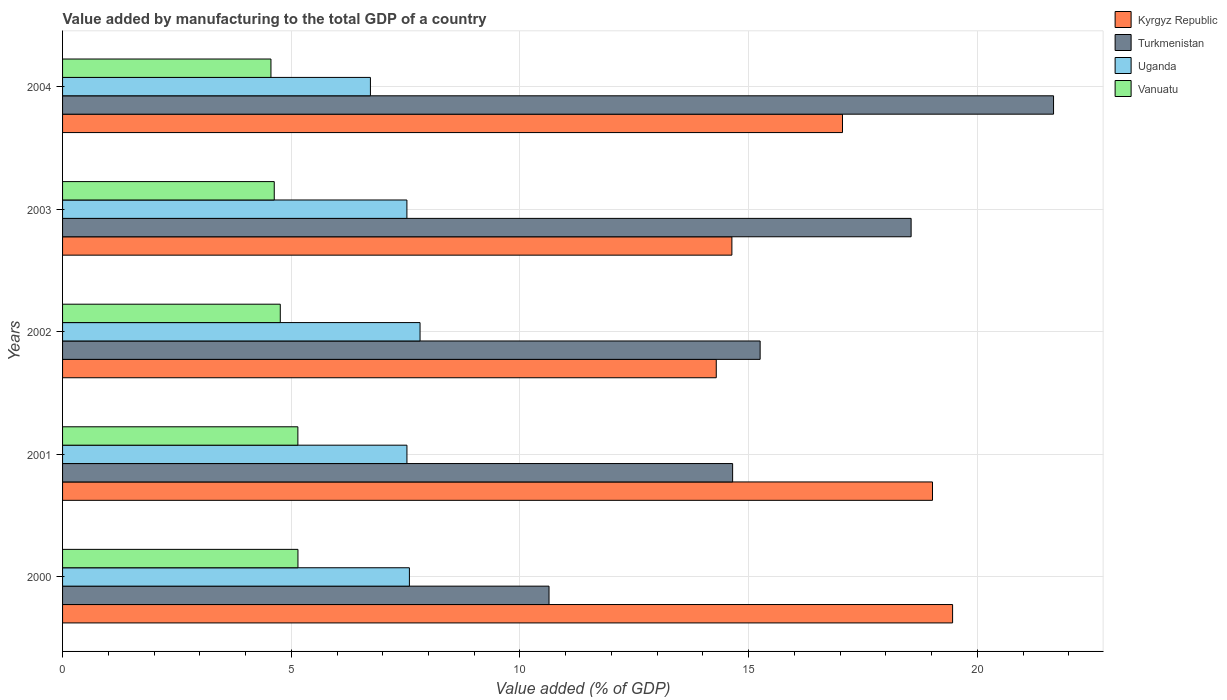How many different coloured bars are there?
Keep it short and to the point. 4. How many groups of bars are there?
Offer a very short reply. 5. How many bars are there on the 4th tick from the top?
Your response must be concise. 4. How many bars are there on the 3rd tick from the bottom?
Offer a very short reply. 4. What is the value added by manufacturing to the total GDP in Turkmenistan in 2000?
Provide a succinct answer. 10.64. Across all years, what is the maximum value added by manufacturing to the total GDP in Turkmenistan?
Your response must be concise. 21.67. Across all years, what is the minimum value added by manufacturing to the total GDP in Kyrgyz Republic?
Your answer should be compact. 14.29. What is the total value added by manufacturing to the total GDP in Uganda in the graph?
Your response must be concise. 37.19. What is the difference between the value added by manufacturing to the total GDP in Uganda in 2003 and that in 2004?
Your answer should be compact. 0.8. What is the difference between the value added by manufacturing to the total GDP in Kyrgyz Republic in 2001 and the value added by manufacturing to the total GDP in Turkmenistan in 2002?
Provide a succinct answer. 3.77. What is the average value added by manufacturing to the total GDP in Kyrgyz Republic per year?
Make the answer very short. 16.89. In the year 2004, what is the difference between the value added by manufacturing to the total GDP in Uganda and value added by manufacturing to the total GDP in Kyrgyz Republic?
Provide a succinct answer. -10.32. What is the ratio of the value added by manufacturing to the total GDP in Kyrgyz Republic in 2000 to that in 2003?
Keep it short and to the point. 1.33. What is the difference between the highest and the second highest value added by manufacturing to the total GDP in Kyrgyz Republic?
Your answer should be very brief. 0.44. What is the difference between the highest and the lowest value added by manufacturing to the total GDP in Uganda?
Keep it short and to the point. 1.09. In how many years, is the value added by manufacturing to the total GDP in Kyrgyz Republic greater than the average value added by manufacturing to the total GDP in Kyrgyz Republic taken over all years?
Provide a succinct answer. 3. Is the sum of the value added by manufacturing to the total GDP in Turkmenistan in 2001 and 2004 greater than the maximum value added by manufacturing to the total GDP in Vanuatu across all years?
Offer a very short reply. Yes. What does the 1st bar from the top in 2001 represents?
Offer a very short reply. Vanuatu. What does the 3rd bar from the bottom in 2004 represents?
Provide a short and direct response. Uganda. Is it the case that in every year, the sum of the value added by manufacturing to the total GDP in Vanuatu and value added by manufacturing to the total GDP in Turkmenistan is greater than the value added by manufacturing to the total GDP in Kyrgyz Republic?
Your answer should be compact. No. How many bars are there?
Keep it short and to the point. 20. Are all the bars in the graph horizontal?
Offer a very short reply. Yes. Where does the legend appear in the graph?
Your answer should be very brief. Top right. How many legend labels are there?
Offer a terse response. 4. How are the legend labels stacked?
Your answer should be very brief. Vertical. What is the title of the graph?
Your answer should be compact. Value added by manufacturing to the total GDP of a country. What is the label or title of the X-axis?
Ensure brevity in your answer.  Value added (% of GDP). What is the label or title of the Y-axis?
Your response must be concise. Years. What is the Value added (% of GDP) of Kyrgyz Republic in 2000?
Your response must be concise. 19.46. What is the Value added (% of GDP) in Turkmenistan in 2000?
Ensure brevity in your answer.  10.64. What is the Value added (% of GDP) in Uganda in 2000?
Make the answer very short. 7.58. What is the Value added (% of GDP) in Vanuatu in 2000?
Offer a very short reply. 5.15. What is the Value added (% of GDP) in Kyrgyz Republic in 2001?
Give a very brief answer. 19.02. What is the Value added (% of GDP) of Turkmenistan in 2001?
Provide a succinct answer. 14.65. What is the Value added (% of GDP) of Uganda in 2001?
Your response must be concise. 7.53. What is the Value added (% of GDP) of Vanuatu in 2001?
Make the answer very short. 5.14. What is the Value added (% of GDP) in Kyrgyz Republic in 2002?
Give a very brief answer. 14.29. What is the Value added (% of GDP) of Turkmenistan in 2002?
Offer a terse response. 15.25. What is the Value added (% of GDP) of Uganda in 2002?
Provide a succinct answer. 7.82. What is the Value added (% of GDP) of Vanuatu in 2002?
Give a very brief answer. 4.76. What is the Value added (% of GDP) in Kyrgyz Republic in 2003?
Give a very brief answer. 14.63. What is the Value added (% of GDP) in Turkmenistan in 2003?
Offer a very short reply. 18.55. What is the Value added (% of GDP) of Uganda in 2003?
Give a very brief answer. 7.53. What is the Value added (% of GDP) of Vanuatu in 2003?
Provide a short and direct response. 4.63. What is the Value added (% of GDP) of Kyrgyz Republic in 2004?
Offer a terse response. 17.05. What is the Value added (% of GDP) in Turkmenistan in 2004?
Ensure brevity in your answer.  21.67. What is the Value added (% of GDP) in Uganda in 2004?
Your response must be concise. 6.73. What is the Value added (% of GDP) of Vanuatu in 2004?
Ensure brevity in your answer.  4.56. Across all years, what is the maximum Value added (% of GDP) of Kyrgyz Republic?
Offer a terse response. 19.46. Across all years, what is the maximum Value added (% of GDP) of Turkmenistan?
Your response must be concise. 21.67. Across all years, what is the maximum Value added (% of GDP) of Uganda?
Provide a short and direct response. 7.82. Across all years, what is the maximum Value added (% of GDP) in Vanuatu?
Offer a very short reply. 5.15. Across all years, what is the minimum Value added (% of GDP) in Kyrgyz Republic?
Your answer should be very brief. 14.29. Across all years, what is the minimum Value added (% of GDP) in Turkmenistan?
Ensure brevity in your answer.  10.64. Across all years, what is the minimum Value added (% of GDP) of Uganda?
Your response must be concise. 6.73. Across all years, what is the minimum Value added (% of GDP) in Vanuatu?
Offer a terse response. 4.56. What is the total Value added (% of GDP) in Kyrgyz Republic in the graph?
Offer a very short reply. 84.46. What is the total Value added (% of GDP) in Turkmenistan in the graph?
Your answer should be very brief. 80.75. What is the total Value added (% of GDP) of Uganda in the graph?
Offer a terse response. 37.19. What is the total Value added (% of GDP) of Vanuatu in the graph?
Offer a very short reply. 24.23. What is the difference between the Value added (% of GDP) of Kyrgyz Republic in 2000 and that in 2001?
Your answer should be compact. 0.44. What is the difference between the Value added (% of GDP) of Turkmenistan in 2000 and that in 2001?
Keep it short and to the point. -4.01. What is the difference between the Value added (% of GDP) in Uganda in 2000 and that in 2001?
Give a very brief answer. 0.05. What is the difference between the Value added (% of GDP) of Vanuatu in 2000 and that in 2001?
Your answer should be compact. 0. What is the difference between the Value added (% of GDP) in Kyrgyz Republic in 2000 and that in 2002?
Keep it short and to the point. 5.17. What is the difference between the Value added (% of GDP) in Turkmenistan in 2000 and that in 2002?
Offer a terse response. -4.62. What is the difference between the Value added (% of GDP) in Uganda in 2000 and that in 2002?
Offer a very short reply. -0.23. What is the difference between the Value added (% of GDP) of Vanuatu in 2000 and that in 2002?
Make the answer very short. 0.39. What is the difference between the Value added (% of GDP) in Kyrgyz Republic in 2000 and that in 2003?
Give a very brief answer. 4.83. What is the difference between the Value added (% of GDP) in Turkmenistan in 2000 and that in 2003?
Offer a very short reply. -7.92. What is the difference between the Value added (% of GDP) in Uganda in 2000 and that in 2003?
Give a very brief answer. 0.05. What is the difference between the Value added (% of GDP) of Vanuatu in 2000 and that in 2003?
Give a very brief answer. 0.52. What is the difference between the Value added (% of GDP) of Kyrgyz Republic in 2000 and that in 2004?
Your response must be concise. 2.41. What is the difference between the Value added (% of GDP) in Turkmenistan in 2000 and that in 2004?
Keep it short and to the point. -11.03. What is the difference between the Value added (% of GDP) in Uganda in 2000 and that in 2004?
Provide a short and direct response. 0.85. What is the difference between the Value added (% of GDP) in Vanuatu in 2000 and that in 2004?
Ensure brevity in your answer.  0.59. What is the difference between the Value added (% of GDP) in Kyrgyz Republic in 2001 and that in 2002?
Your answer should be compact. 4.73. What is the difference between the Value added (% of GDP) of Turkmenistan in 2001 and that in 2002?
Provide a succinct answer. -0.6. What is the difference between the Value added (% of GDP) in Uganda in 2001 and that in 2002?
Your response must be concise. -0.29. What is the difference between the Value added (% of GDP) in Vanuatu in 2001 and that in 2002?
Your answer should be very brief. 0.38. What is the difference between the Value added (% of GDP) of Kyrgyz Republic in 2001 and that in 2003?
Offer a very short reply. 4.39. What is the difference between the Value added (% of GDP) of Turkmenistan in 2001 and that in 2003?
Offer a terse response. -3.9. What is the difference between the Value added (% of GDP) of Vanuatu in 2001 and that in 2003?
Your answer should be compact. 0.52. What is the difference between the Value added (% of GDP) in Kyrgyz Republic in 2001 and that in 2004?
Give a very brief answer. 1.97. What is the difference between the Value added (% of GDP) of Turkmenistan in 2001 and that in 2004?
Ensure brevity in your answer.  -7.02. What is the difference between the Value added (% of GDP) in Uganda in 2001 and that in 2004?
Make the answer very short. 0.8. What is the difference between the Value added (% of GDP) in Vanuatu in 2001 and that in 2004?
Provide a succinct answer. 0.59. What is the difference between the Value added (% of GDP) of Kyrgyz Republic in 2002 and that in 2003?
Your response must be concise. -0.34. What is the difference between the Value added (% of GDP) in Turkmenistan in 2002 and that in 2003?
Keep it short and to the point. -3.3. What is the difference between the Value added (% of GDP) of Uganda in 2002 and that in 2003?
Offer a terse response. 0.29. What is the difference between the Value added (% of GDP) of Vanuatu in 2002 and that in 2003?
Offer a very short reply. 0.13. What is the difference between the Value added (% of GDP) in Kyrgyz Republic in 2002 and that in 2004?
Provide a short and direct response. -2.76. What is the difference between the Value added (% of GDP) in Turkmenistan in 2002 and that in 2004?
Ensure brevity in your answer.  -6.42. What is the difference between the Value added (% of GDP) of Uganda in 2002 and that in 2004?
Offer a terse response. 1.08. What is the difference between the Value added (% of GDP) in Vanuatu in 2002 and that in 2004?
Your answer should be compact. 0.2. What is the difference between the Value added (% of GDP) in Kyrgyz Republic in 2003 and that in 2004?
Ensure brevity in your answer.  -2.42. What is the difference between the Value added (% of GDP) of Turkmenistan in 2003 and that in 2004?
Your answer should be very brief. -3.11. What is the difference between the Value added (% of GDP) of Uganda in 2003 and that in 2004?
Provide a succinct answer. 0.8. What is the difference between the Value added (% of GDP) in Vanuatu in 2003 and that in 2004?
Your answer should be compact. 0.07. What is the difference between the Value added (% of GDP) of Kyrgyz Republic in 2000 and the Value added (% of GDP) of Turkmenistan in 2001?
Give a very brief answer. 4.81. What is the difference between the Value added (% of GDP) of Kyrgyz Republic in 2000 and the Value added (% of GDP) of Uganda in 2001?
Offer a terse response. 11.93. What is the difference between the Value added (% of GDP) in Kyrgyz Republic in 2000 and the Value added (% of GDP) in Vanuatu in 2001?
Your answer should be very brief. 14.31. What is the difference between the Value added (% of GDP) of Turkmenistan in 2000 and the Value added (% of GDP) of Uganda in 2001?
Your answer should be compact. 3.11. What is the difference between the Value added (% of GDP) in Turkmenistan in 2000 and the Value added (% of GDP) in Vanuatu in 2001?
Provide a short and direct response. 5.49. What is the difference between the Value added (% of GDP) in Uganda in 2000 and the Value added (% of GDP) in Vanuatu in 2001?
Offer a terse response. 2.44. What is the difference between the Value added (% of GDP) in Kyrgyz Republic in 2000 and the Value added (% of GDP) in Turkmenistan in 2002?
Your answer should be compact. 4.21. What is the difference between the Value added (% of GDP) of Kyrgyz Republic in 2000 and the Value added (% of GDP) of Uganda in 2002?
Your response must be concise. 11.64. What is the difference between the Value added (% of GDP) in Kyrgyz Republic in 2000 and the Value added (% of GDP) in Vanuatu in 2002?
Give a very brief answer. 14.7. What is the difference between the Value added (% of GDP) in Turkmenistan in 2000 and the Value added (% of GDP) in Uganda in 2002?
Provide a succinct answer. 2.82. What is the difference between the Value added (% of GDP) in Turkmenistan in 2000 and the Value added (% of GDP) in Vanuatu in 2002?
Offer a very short reply. 5.88. What is the difference between the Value added (% of GDP) in Uganda in 2000 and the Value added (% of GDP) in Vanuatu in 2002?
Give a very brief answer. 2.82. What is the difference between the Value added (% of GDP) of Kyrgyz Republic in 2000 and the Value added (% of GDP) of Turkmenistan in 2003?
Give a very brief answer. 0.91. What is the difference between the Value added (% of GDP) of Kyrgyz Republic in 2000 and the Value added (% of GDP) of Uganda in 2003?
Offer a terse response. 11.93. What is the difference between the Value added (% of GDP) of Kyrgyz Republic in 2000 and the Value added (% of GDP) of Vanuatu in 2003?
Ensure brevity in your answer.  14.83. What is the difference between the Value added (% of GDP) in Turkmenistan in 2000 and the Value added (% of GDP) in Uganda in 2003?
Offer a very short reply. 3.11. What is the difference between the Value added (% of GDP) of Turkmenistan in 2000 and the Value added (% of GDP) of Vanuatu in 2003?
Offer a very short reply. 6.01. What is the difference between the Value added (% of GDP) of Uganda in 2000 and the Value added (% of GDP) of Vanuatu in 2003?
Give a very brief answer. 2.95. What is the difference between the Value added (% of GDP) of Kyrgyz Republic in 2000 and the Value added (% of GDP) of Turkmenistan in 2004?
Your answer should be compact. -2.21. What is the difference between the Value added (% of GDP) in Kyrgyz Republic in 2000 and the Value added (% of GDP) in Uganda in 2004?
Give a very brief answer. 12.73. What is the difference between the Value added (% of GDP) of Kyrgyz Republic in 2000 and the Value added (% of GDP) of Vanuatu in 2004?
Offer a terse response. 14.9. What is the difference between the Value added (% of GDP) of Turkmenistan in 2000 and the Value added (% of GDP) of Uganda in 2004?
Your answer should be compact. 3.9. What is the difference between the Value added (% of GDP) in Turkmenistan in 2000 and the Value added (% of GDP) in Vanuatu in 2004?
Your response must be concise. 6.08. What is the difference between the Value added (% of GDP) of Uganda in 2000 and the Value added (% of GDP) of Vanuatu in 2004?
Your response must be concise. 3.03. What is the difference between the Value added (% of GDP) of Kyrgyz Republic in 2001 and the Value added (% of GDP) of Turkmenistan in 2002?
Ensure brevity in your answer.  3.77. What is the difference between the Value added (% of GDP) in Kyrgyz Republic in 2001 and the Value added (% of GDP) in Uganda in 2002?
Ensure brevity in your answer.  11.2. What is the difference between the Value added (% of GDP) in Kyrgyz Republic in 2001 and the Value added (% of GDP) in Vanuatu in 2002?
Your response must be concise. 14.26. What is the difference between the Value added (% of GDP) in Turkmenistan in 2001 and the Value added (% of GDP) in Uganda in 2002?
Make the answer very short. 6.83. What is the difference between the Value added (% of GDP) of Turkmenistan in 2001 and the Value added (% of GDP) of Vanuatu in 2002?
Keep it short and to the point. 9.89. What is the difference between the Value added (% of GDP) in Uganda in 2001 and the Value added (% of GDP) in Vanuatu in 2002?
Offer a terse response. 2.77. What is the difference between the Value added (% of GDP) in Kyrgyz Republic in 2001 and the Value added (% of GDP) in Turkmenistan in 2003?
Make the answer very short. 0.47. What is the difference between the Value added (% of GDP) of Kyrgyz Republic in 2001 and the Value added (% of GDP) of Uganda in 2003?
Make the answer very short. 11.49. What is the difference between the Value added (% of GDP) in Kyrgyz Republic in 2001 and the Value added (% of GDP) in Vanuatu in 2003?
Your answer should be very brief. 14.39. What is the difference between the Value added (% of GDP) of Turkmenistan in 2001 and the Value added (% of GDP) of Uganda in 2003?
Make the answer very short. 7.12. What is the difference between the Value added (% of GDP) in Turkmenistan in 2001 and the Value added (% of GDP) in Vanuatu in 2003?
Your answer should be compact. 10.02. What is the difference between the Value added (% of GDP) of Uganda in 2001 and the Value added (% of GDP) of Vanuatu in 2003?
Ensure brevity in your answer.  2.9. What is the difference between the Value added (% of GDP) in Kyrgyz Republic in 2001 and the Value added (% of GDP) in Turkmenistan in 2004?
Offer a very short reply. -2.65. What is the difference between the Value added (% of GDP) of Kyrgyz Republic in 2001 and the Value added (% of GDP) of Uganda in 2004?
Ensure brevity in your answer.  12.29. What is the difference between the Value added (% of GDP) in Kyrgyz Republic in 2001 and the Value added (% of GDP) in Vanuatu in 2004?
Ensure brevity in your answer.  14.46. What is the difference between the Value added (% of GDP) of Turkmenistan in 2001 and the Value added (% of GDP) of Uganda in 2004?
Make the answer very short. 7.92. What is the difference between the Value added (% of GDP) in Turkmenistan in 2001 and the Value added (% of GDP) in Vanuatu in 2004?
Your response must be concise. 10.09. What is the difference between the Value added (% of GDP) of Uganda in 2001 and the Value added (% of GDP) of Vanuatu in 2004?
Offer a terse response. 2.97. What is the difference between the Value added (% of GDP) in Kyrgyz Republic in 2002 and the Value added (% of GDP) in Turkmenistan in 2003?
Give a very brief answer. -4.26. What is the difference between the Value added (% of GDP) in Kyrgyz Republic in 2002 and the Value added (% of GDP) in Uganda in 2003?
Your answer should be compact. 6.76. What is the difference between the Value added (% of GDP) of Kyrgyz Republic in 2002 and the Value added (% of GDP) of Vanuatu in 2003?
Make the answer very short. 9.66. What is the difference between the Value added (% of GDP) of Turkmenistan in 2002 and the Value added (% of GDP) of Uganda in 2003?
Give a very brief answer. 7.72. What is the difference between the Value added (% of GDP) of Turkmenistan in 2002 and the Value added (% of GDP) of Vanuatu in 2003?
Offer a terse response. 10.62. What is the difference between the Value added (% of GDP) of Uganda in 2002 and the Value added (% of GDP) of Vanuatu in 2003?
Offer a very short reply. 3.19. What is the difference between the Value added (% of GDP) in Kyrgyz Republic in 2002 and the Value added (% of GDP) in Turkmenistan in 2004?
Your response must be concise. -7.37. What is the difference between the Value added (% of GDP) of Kyrgyz Republic in 2002 and the Value added (% of GDP) of Uganda in 2004?
Offer a terse response. 7.56. What is the difference between the Value added (% of GDP) in Kyrgyz Republic in 2002 and the Value added (% of GDP) in Vanuatu in 2004?
Ensure brevity in your answer.  9.74. What is the difference between the Value added (% of GDP) in Turkmenistan in 2002 and the Value added (% of GDP) in Uganda in 2004?
Keep it short and to the point. 8.52. What is the difference between the Value added (% of GDP) in Turkmenistan in 2002 and the Value added (% of GDP) in Vanuatu in 2004?
Your answer should be compact. 10.7. What is the difference between the Value added (% of GDP) in Uganda in 2002 and the Value added (% of GDP) in Vanuatu in 2004?
Your answer should be very brief. 3.26. What is the difference between the Value added (% of GDP) of Kyrgyz Republic in 2003 and the Value added (% of GDP) of Turkmenistan in 2004?
Your answer should be compact. -7.03. What is the difference between the Value added (% of GDP) in Kyrgyz Republic in 2003 and the Value added (% of GDP) in Uganda in 2004?
Ensure brevity in your answer.  7.9. What is the difference between the Value added (% of GDP) of Kyrgyz Republic in 2003 and the Value added (% of GDP) of Vanuatu in 2004?
Make the answer very short. 10.08. What is the difference between the Value added (% of GDP) in Turkmenistan in 2003 and the Value added (% of GDP) in Uganda in 2004?
Offer a terse response. 11.82. What is the difference between the Value added (% of GDP) in Turkmenistan in 2003 and the Value added (% of GDP) in Vanuatu in 2004?
Keep it short and to the point. 14. What is the difference between the Value added (% of GDP) of Uganda in 2003 and the Value added (% of GDP) of Vanuatu in 2004?
Your response must be concise. 2.97. What is the average Value added (% of GDP) of Kyrgyz Republic per year?
Your answer should be very brief. 16.89. What is the average Value added (% of GDP) in Turkmenistan per year?
Give a very brief answer. 16.15. What is the average Value added (% of GDP) of Uganda per year?
Keep it short and to the point. 7.44. What is the average Value added (% of GDP) in Vanuatu per year?
Give a very brief answer. 4.85. In the year 2000, what is the difference between the Value added (% of GDP) of Kyrgyz Republic and Value added (% of GDP) of Turkmenistan?
Keep it short and to the point. 8.82. In the year 2000, what is the difference between the Value added (% of GDP) in Kyrgyz Republic and Value added (% of GDP) in Uganda?
Provide a short and direct response. 11.88. In the year 2000, what is the difference between the Value added (% of GDP) in Kyrgyz Republic and Value added (% of GDP) in Vanuatu?
Your answer should be compact. 14.31. In the year 2000, what is the difference between the Value added (% of GDP) in Turkmenistan and Value added (% of GDP) in Uganda?
Your answer should be very brief. 3.05. In the year 2000, what is the difference between the Value added (% of GDP) in Turkmenistan and Value added (% of GDP) in Vanuatu?
Your answer should be compact. 5.49. In the year 2000, what is the difference between the Value added (% of GDP) in Uganda and Value added (% of GDP) in Vanuatu?
Offer a very short reply. 2.44. In the year 2001, what is the difference between the Value added (% of GDP) of Kyrgyz Republic and Value added (% of GDP) of Turkmenistan?
Make the answer very short. 4.37. In the year 2001, what is the difference between the Value added (% of GDP) of Kyrgyz Republic and Value added (% of GDP) of Uganda?
Ensure brevity in your answer.  11.49. In the year 2001, what is the difference between the Value added (% of GDP) of Kyrgyz Republic and Value added (% of GDP) of Vanuatu?
Ensure brevity in your answer.  13.87. In the year 2001, what is the difference between the Value added (% of GDP) of Turkmenistan and Value added (% of GDP) of Uganda?
Keep it short and to the point. 7.12. In the year 2001, what is the difference between the Value added (% of GDP) in Turkmenistan and Value added (% of GDP) in Vanuatu?
Keep it short and to the point. 9.51. In the year 2001, what is the difference between the Value added (% of GDP) of Uganda and Value added (% of GDP) of Vanuatu?
Your response must be concise. 2.38. In the year 2002, what is the difference between the Value added (% of GDP) in Kyrgyz Republic and Value added (% of GDP) in Turkmenistan?
Keep it short and to the point. -0.96. In the year 2002, what is the difference between the Value added (% of GDP) in Kyrgyz Republic and Value added (% of GDP) in Uganda?
Give a very brief answer. 6.48. In the year 2002, what is the difference between the Value added (% of GDP) of Kyrgyz Republic and Value added (% of GDP) of Vanuatu?
Provide a succinct answer. 9.53. In the year 2002, what is the difference between the Value added (% of GDP) in Turkmenistan and Value added (% of GDP) in Uganda?
Make the answer very short. 7.44. In the year 2002, what is the difference between the Value added (% of GDP) of Turkmenistan and Value added (% of GDP) of Vanuatu?
Offer a very short reply. 10.49. In the year 2002, what is the difference between the Value added (% of GDP) in Uganda and Value added (% of GDP) in Vanuatu?
Give a very brief answer. 3.06. In the year 2003, what is the difference between the Value added (% of GDP) of Kyrgyz Republic and Value added (% of GDP) of Turkmenistan?
Your response must be concise. -3.92. In the year 2003, what is the difference between the Value added (% of GDP) in Kyrgyz Republic and Value added (% of GDP) in Uganda?
Make the answer very short. 7.11. In the year 2003, what is the difference between the Value added (% of GDP) in Kyrgyz Republic and Value added (% of GDP) in Vanuatu?
Offer a terse response. 10.01. In the year 2003, what is the difference between the Value added (% of GDP) in Turkmenistan and Value added (% of GDP) in Uganda?
Your response must be concise. 11.02. In the year 2003, what is the difference between the Value added (% of GDP) in Turkmenistan and Value added (% of GDP) in Vanuatu?
Your answer should be compact. 13.92. In the year 2003, what is the difference between the Value added (% of GDP) in Uganda and Value added (% of GDP) in Vanuatu?
Offer a terse response. 2.9. In the year 2004, what is the difference between the Value added (% of GDP) in Kyrgyz Republic and Value added (% of GDP) in Turkmenistan?
Keep it short and to the point. -4.61. In the year 2004, what is the difference between the Value added (% of GDP) in Kyrgyz Republic and Value added (% of GDP) in Uganda?
Your response must be concise. 10.32. In the year 2004, what is the difference between the Value added (% of GDP) of Kyrgyz Republic and Value added (% of GDP) of Vanuatu?
Your response must be concise. 12.5. In the year 2004, what is the difference between the Value added (% of GDP) in Turkmenistan and Value added (% of GDP) in Uganda?
Give a very brief answer. 14.94. In the year 2004, what is the difference between the Value added (% of GDP) in Turkmenistan and Value added (% of GDP) in Vanuatu?
Keep it short and to the point. 17.11. In the year 2004, what is the difference between the Value added (% of GDP) in Uganda and Value added (% of GDP) in Vanuatu?
Your response must be concise. 2.17. What is the ratio of the Value added (% of GDP) of Kyrgyz Republic in 2000 to that in 2001?
Make the answer very short. 1.02. What is the ratio of the Value added (% of GDP) of Turkmenistan in 2000 to that in 2001?
Give a very brief answer. 0.73. What is the ratio of the Value added (% of GDP) in Uganda in 2000 to that in 2001?
Your response must be concise. 1.01. What is the ratio of the Value added (% of GDP) in Vanuatu in 2000 to that in 2001?
Your answer should be compact. 1. What is the ratio of the Value added (% of GDP) of Kyrgyz Republic in 2000 to that in 2002?
Your response must be concise. 1.36. What is the ratio of the Value added (% of GDP) of Turkmenistan in 2000 to that in 2002?
Your response must be concise. 0.7. What is the ratio of the Value added (% of GDP) of Uganda in 2000 to that in 2002?
Offer a very short reply. 0.97. What is the ratio of the Value added (% of GDP) in Vanuatu in 2000 to that in 2002?
Provide a short and direct response. 1.08. What is the ratio of the Value added (% of GDP) in Kyrgyz Republic in 2000 to that in 2003?
Make the answer very short. 1.33. What is the ratio of the Value added (% of GDP) in Turkmenistan in 2000 to that in 2003?
Make the answer very short. 0.57. What is the ratio of the Value added (% of GDP) of Uganda in 2000 to that in 2003?
Keep it short and to the point. 1.01. What is the ratio of the Value added (% of GDP) of Vanuatu in 2000 to that in 2003?
Ensure brevity in your answer.  1.11. What is the ratio of the Value added (% of GDP) of Kyrgyz Republic in 2000 to that in 2004?
Your response must be concise. 1.14. What is the ratio of the Value added (% of GDP) of Turkmenistan in 2000 to that in 2004?
Provide a short and direct response. 0.49. What is the ratio of the Value added (% of GDP) in Uganda in 2000 to that in 2004?
Your answer should be compact. 1.13. What is the ratio of the Value added (% of GDP) of Vanuatu in 2000 to that in 2004?
Offer a very short reply. 1.13. What is the ratio of the Value added (% of GDP) in Kyrgyz Republic in 2001 to that in 2002?
Provide a short and direct response. 1.33. What is the ratio of the Value added (% of GDP) of Turkmenistan in 2001 to that in 2002?
Give a very brief answer. 0.96. What is the ratio of the Value added (% of GDP) of Uganda in 2001 to that in 2002?
Your answer should be compact. 0.96. What is the ratio of the Value added (% of GDP) in Vanuatu in 2001 to that in 2002?
Your response must be concise. 1.08. What is the ratio of the Value added (% of GDP) in Kyrgyz Republic in 2001 to that in 2003?
Give a very brief answer. 1.3. What is the ratio of the Value added (% of GDP) of Turkmenistan in 2001 to that in 2003?
Provide a short and direct response. 0.79. What is the ratio of the Value added (% of GDP) in Uganda in 2001 to that in 2003?
Your answer should be very brief. 1. What is the ratio of the Value added (% of GDP) of Vanuatu in 2001 to that in 2003?
Provide a succinct answer. 1.11. What is the ratio of the Value added (% of GDP) in Kyrgyz Republic in 2001 to that in 2004?
Your answer should be compact. 1.12. What is the ratio of the Value added (% of GDP) of Turkmenistan in 2001 to that in 2004?
Your response must be concise. 0.68. What is the ratio of the Value added (% of GDP) in Uganda in 2001 to that in 2004?
Your response must be concise. 1.12. What is the ratio of the Value added (% of GDP) of Vanuatu in 2001 to that in 2004?
Offer a very short reply. 1.13. What is the ratio of the Value added (% of GDP) in Kyrgyz Republic in 2002 to that in 2003?
Give a very brief answer. 0.98. What is the ratio of the Value added (% of GDP) of Turkmenistan in 2002 to that in 2003?
Offer a terse response. 0.82. What is the ratio of the Value added (% of GDP) of Uganda in 2002 to that in 2003?
Your answer should be very brief. 1.04. What is the ratio of the Value added (% of GDP) of Vanuatu in 2002 to that in 2003?
Make the answer very short. 1.03. What is the ratio of the Value added (% of GDP) in Kyrgyz Republic in 2002 to that in 2004?
Give a very brief answer. 0.84. What is the ratio of the Value added (% of GDP) in Turkmenistan in 2002 to that in 2004?
Provide a succinct answer. 0.7. What is the ratio of the Value added (% of GDP) of Uganda in 2002 to that in 2004?
Your answer should be compact. 1.16. What is the ratio of the Value added (% of GDP) in Vanuatu in 2002 to that in 2004?
Your response must be concise. 1.04. What is the ratio of the Value added (% of GDP) of Kyrgyz Republic in 2003 to that in 2004?
Make the answer very short. 0.86. What is the ratio of the Value added (% of GDP) of Turkmenistan in 2003 to that in 2004?
Provide a short and direct response. 0.86. What is the ratio of the Value added (% of GDP) in Uganda in 2003 to that in 2004?
Make the answer very short. 1.12. What is the ratio of the Value added (% of GDP) in Vanuatu in 2003 to that in 2004?
Your response must be concise. 1.02. What is the difference between the highest and the second highest Value added (% of GDP) of Kyrgyz Republic?
Your answer should be very brief. 0.44. What is the difference between the highest and the second highest Value added (% of GDP) in Turkmenistan?
Your answer should be compact. 3.11. What is the difference between the highest and the second highest Value added (% of GDP) in Uganda?
Offer a very short reply. 0.23. What is the difference between the highest and the second highest Value added (% of GDP) of Vanuatu?
Provide a succinct answer. 0. What is the difference between the highest and the lowest Value added (% of GDP) in Kyrgyz Republic?
Your answer should be very brief. 5.17. What is the difference between the highest and the lowest Value added (% of GDP) in Turkmenistan?
Provide a succinct answer. 11.03. What is the difference between the highest and the lowest Value added (% of GDP) in Uganda?
Make the answer very short. 1.08. What is the difference between the highest and the lowest Value added (% of GDP) in Vanuatu?
Your answer should be compact. 0.59. 